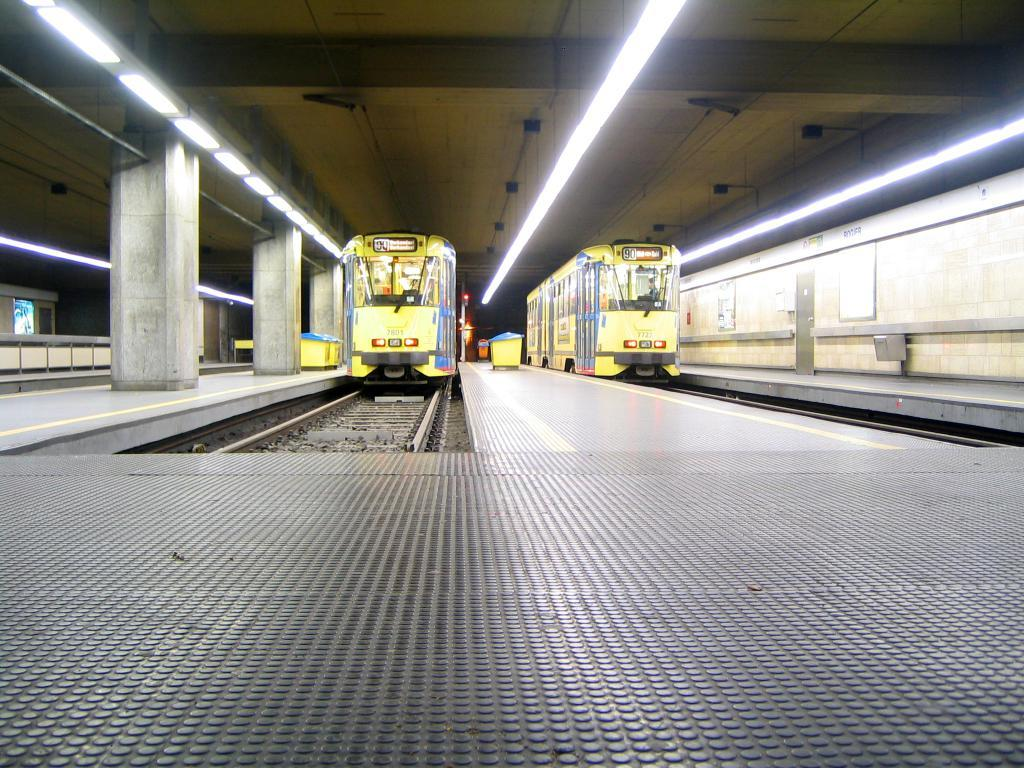What type of vehicles can be seen on the track in the image? There are trains on the track in the image. What type of containers are present in the image? There are bins in the image. What type of structures support the ceiling in the image? There are pillars in the image. What type of barrier is present in the image? There is a wall in the image. What type of signage is present in the image? There is a board in the image. What type of advertisement is present in the image? There is a hoarding in the image. What type of illumination is present in the image? There are lights in the image. What type of overhead covering is present in the image? There is a ceiling in the image. Can you tell me the price of the baseball bat in the image? There is no baseball bat present in the image, so it is not possible to determine its price. 